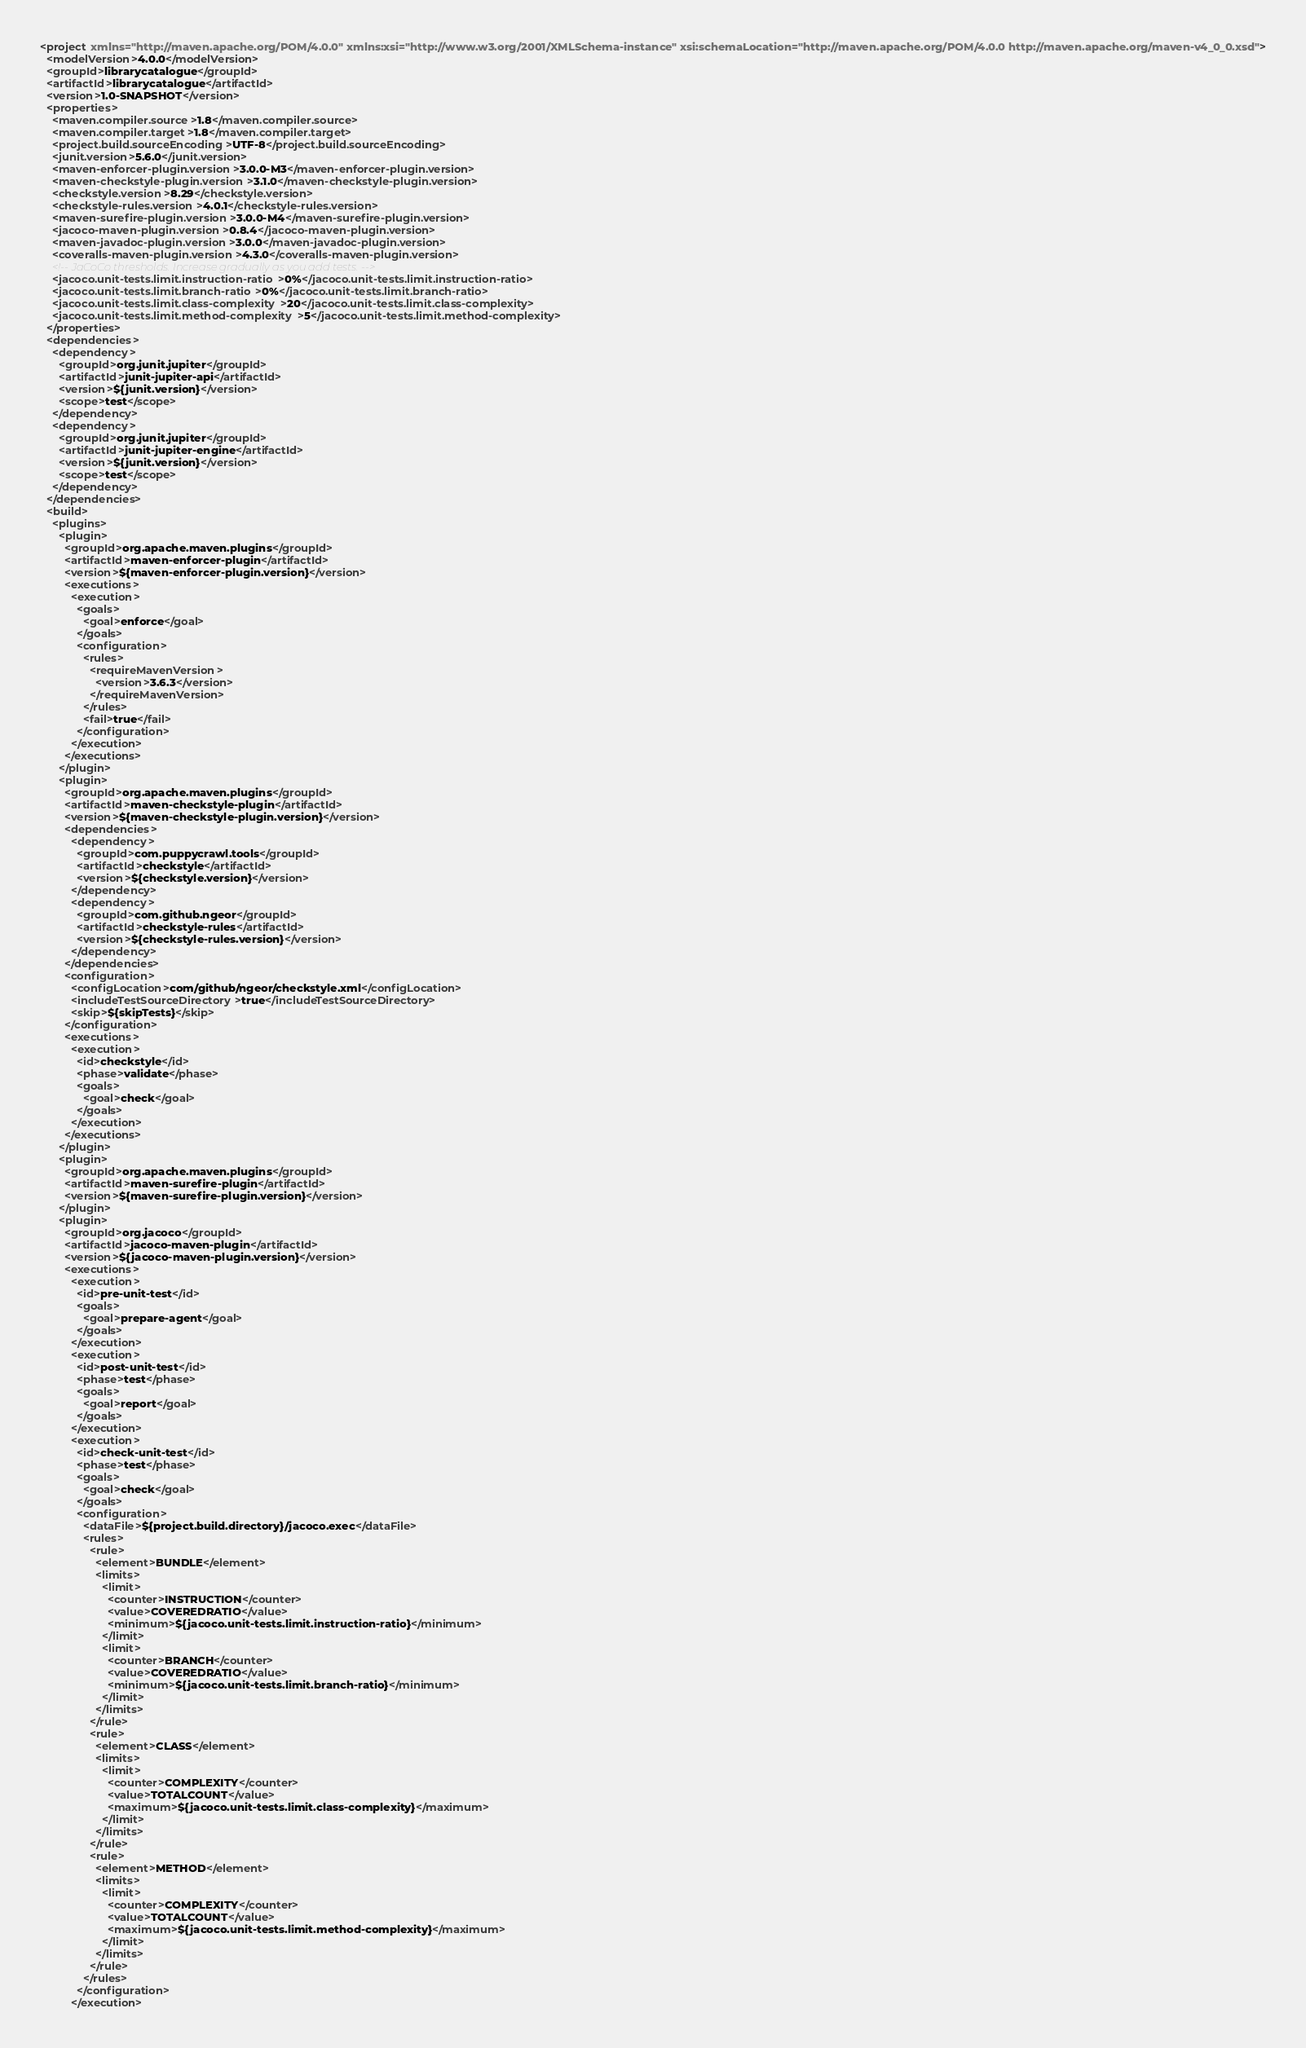Convert code to text. <code><loc_0><loc_0><loc_500><loc_500><_XML_><project xmlns="http://maven.apache.org/POM/4.0.0" xmlns:xsi="http://www.w3.org/2001/XMLSchema-instance" xsi:schemaLocation="http://maven.apache.org/POM/4.0.0 http://maven.apache.org/maven-v4_0_0.xsd">
  <modelVersion>4.0.0</modelVersion>
  <groupId>librarycatalogue</groupId>
  <artifactId>librarycatalogue</artifactId>
  <version>1.0-SNAPSHOT</version>
  <properties>
    <maven.compiler.source>1.8</maven.compiler.source>
    <maven.compiler.target>1.8</maven.compiler.target>
    <project.build.sourceEncoding>UTF-8</project.build.sourceEncoding>
    <junit.version>5.6.0</junit.version>
    <maven-enforcer-plugin.version>3.0.0-M3</maven-enforcer-plugin.version>
    <maven-checkstyle-plugin.version>3.1.0</maven-checkstyle-plugin.version>
    <checkstyle.version>8.29</checkstyle.version>
    <checkstyle-rules.version>4.0.1</checkstyle-rules.version>
    <maven-surefire-plugin.version>3.0.0-M4</maven-surefire-plugin.version>
    <jacoco-maven-plugin.version>0.8.4</jacoco-maven-plugin.version>
    <maven-javadoc-plugin.version>3.0.0</maven-javadoc-plugin.version>
    <coveralls-maven-plugin.version>4.3.0</coveralls-maven-plugin.version>
    <!-- JaCoCo thresholds. Increase gradually as you add tests. -->
    <jacoco.unit-tests.limit.instruction-ratio>0%</jacoco.unit-tests.limit.instruction-ratio>
    <jacoco.unit-tests.limit.branch-ratio>0%</jacoco.unit-tests.limit.branch-ratio>
    <jacoco.unit-tests.limit.class-complexity>20</jacoco.unit-tests.limit.class-complexity>
    <jacoco.unit-tests.limit.method-complexity>5</jacoco.unit-tests.limit.method-complexity>
  </properties>
  <dependencies>
    <dependency>
      <groupId>org.junit.jupiter</groupId>
      <artifactId>junit-jupiter-api</artifactId>
      <version>${junit.version}</version>
      <scope>test</scope>
    </dependency>
    <dependency>
      <groupId>org.junit.jupiter</groupId>
      <artifactId>junit-jupiter-engine</artifactId>
      <version>${junit.version}</version>
      <scope>test</scope>
    </dependency>
  </dependencies>
  <build>
    <plugins>
      <plugin>
        <groupId>org.apache.maven.plugins</groupId>
        <artifactId>maven-enforcer-plugin</artifactId>
        <version>${maven-enforcer-plugin.version}</version>
        <executions>
          <execution>
            <goals>
              <goal>enforce</goal>
            </goals>
            <configuration>
              <rules>
                <requireMavenVersion>
                  <version>3.6.3</version>
                </requireMavenVersion>
              </rules>
              <fail>true</fail>
            </configuration>
          </execution>
        </executions>
      </plugin>
      <plugin>
        <groupId>org.apache.maven.plugins</groupId>
        <artifactId>maven-checkstyle-plugin</artifactId>
        <version>${maven-checkstyle-plugin.version}</version>
        <dependencies>
          <dependency>
            <groupId>com.puppycrawl.tools</groupId>
            <artifactId>checkstyle</artifactId>
            <version>${checkstyle.version}</version>
          </dependency>
          <dependency>
            <groupId>com.github.ngeor</groupId>
            <artifactId>checkstyle-rules</artifactId>
            <version>${checkstyle-rules.version}</version>
          </dependency>
        </dependencies>
        <configuration>
          <configLocation>com/github/ngeor/checkstyle.xml</configLocation>
          <includeTestSourceDirectory>true</includeTestSourceDirectory>
          <skip>${skipTests}</skip>
        </configuration>
        <executions>
          <execution>
            <id>checkstyle</id>
            <phase>validate</phase>
            <goals>
              <goal>check</goal>
            </goals>
          </execution>
        </executions>
      </plugin>
      <plugin>
        <groupId>org.apache.maven.plugins</groupId>
        <artifactId>maven-surefire-plugin</artifactId>
        <version>${maven-surefire-plugin.version}</version>
      </plugin>
      <plugin>
        <groupId>org.jacoco</groupId>
        <artifactId>jacoco-maven-plugin</artifactId>
        <version>${jacoco-maven-plugin.version}</version>
        <executions>
          <execution>
            <id>pre-unit-test</id>
            <goals>
              <goal>prepare-agent</goal>
            </goals>
          </execution>
          <execution>
            <id>post-unit-test</id>
            <phase>test</phase>
            <goals>
              <goal>report</goal>
            </goals>
          </execution>
          <execution>
            <id>check-unit-test</id>
            <phase>test</phase>
            <goals>
              <goal>check</goal>
            </goals>
            <configuration>
              <dataFile>${project.build.directory}/jacoco.exec</dataFile>
              <rules>
                <rule>
                  <element>BUNDLE</element>
                  <limits>
                    <limit>
                      <counter>INSTRUCTION</counter>
                      <value>COVEREDRATIO</value>
                      <minimum>${jacoco.unit-tests.limit.instruction-ratio}</minimum>
                    </limit>
                    <limit>
                      <counter>BRANCH</counter>
                      <value>COVEREDRATIO</value>
                      <minimum>${jacoco.unit-tests.limit.branch-ratio}</minimum>
                    </limit>
                  </limits>
                </rule>
                <rule>
                  <element>CLASS</element>
                  <limits>
                    <limit>
                      <counter>COMPLEXITY</counter>
                      <value>TOTALCOUNT</value>
                      <maximum>${jacoco.unit-tests.limit.class-complexity}</maximum>
                    </limit>
                  </limits>
                </rule>
                <rule>
                  <element>METHOD</element>
                  <limits>
                    <limit>
                      <counter>COMPLEXITY</counter>
                      <value>TOTALCOUNT</value>
                      <maximum>${jacoco.unit-tests.limit.method-complexity}</maximum>
                    </limit>
                  </limits>
                </rule>
              </rules>
            </configuration>
          </execution></code> 